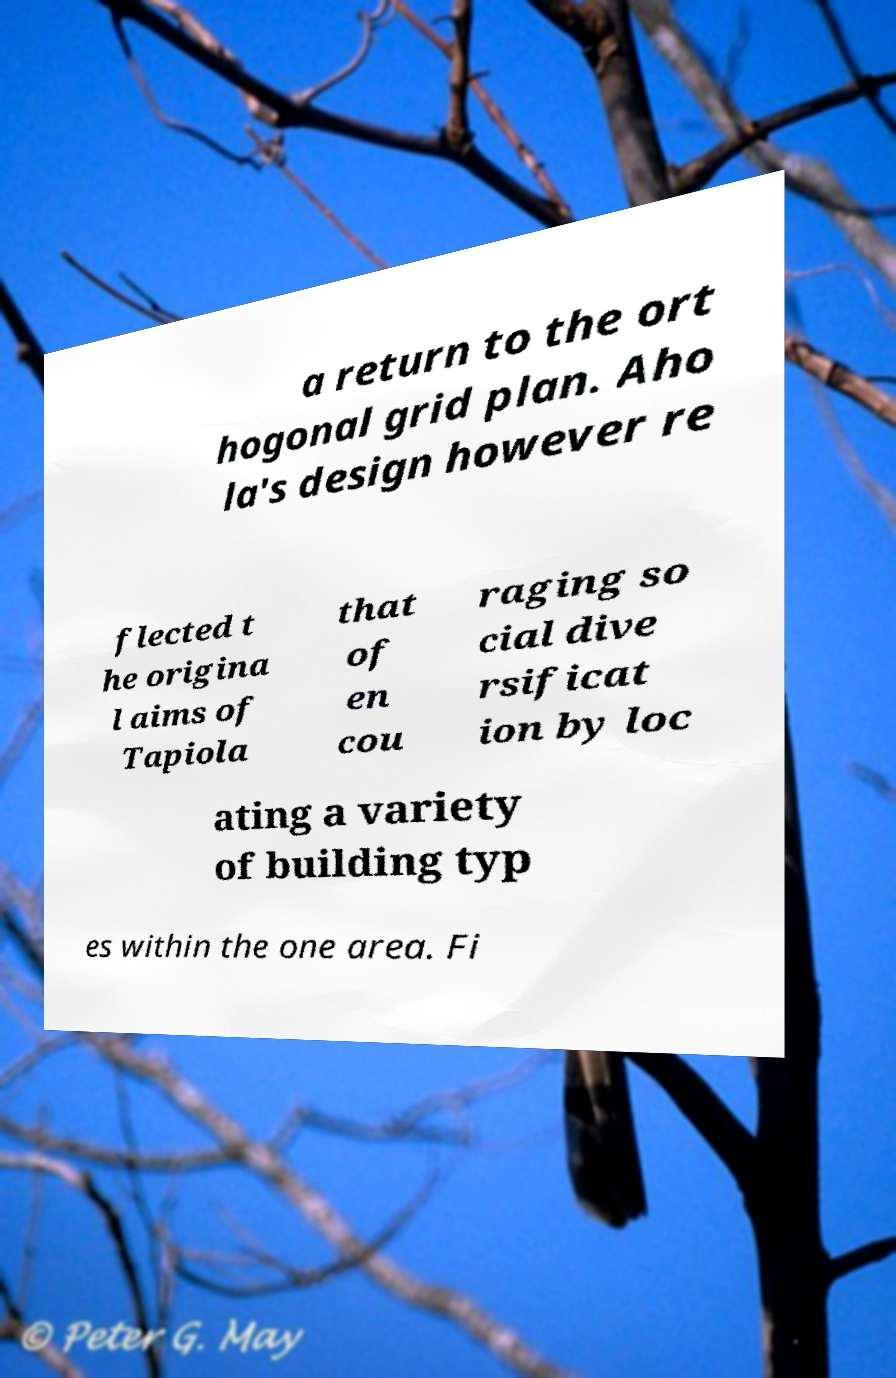Can you accurately transcribe the text from the provided image for me? a return to the ort hogonal grid plan. Aho la's design however re flected t he origina l aims of Tapiola that of en cou raging so cial dive rsificat ion by loc ating a variety of building typ es within the one area. Fi 